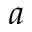<formula> <loc_0><loc_0><loc_500><loc_500>a</formula> 